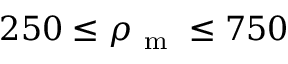Convert formula to latex. <formula><loc_0><loc_0><loc_500><loc_500>2 5 0 \leq \rho _ { m } \leq 7 5 0</formula> 